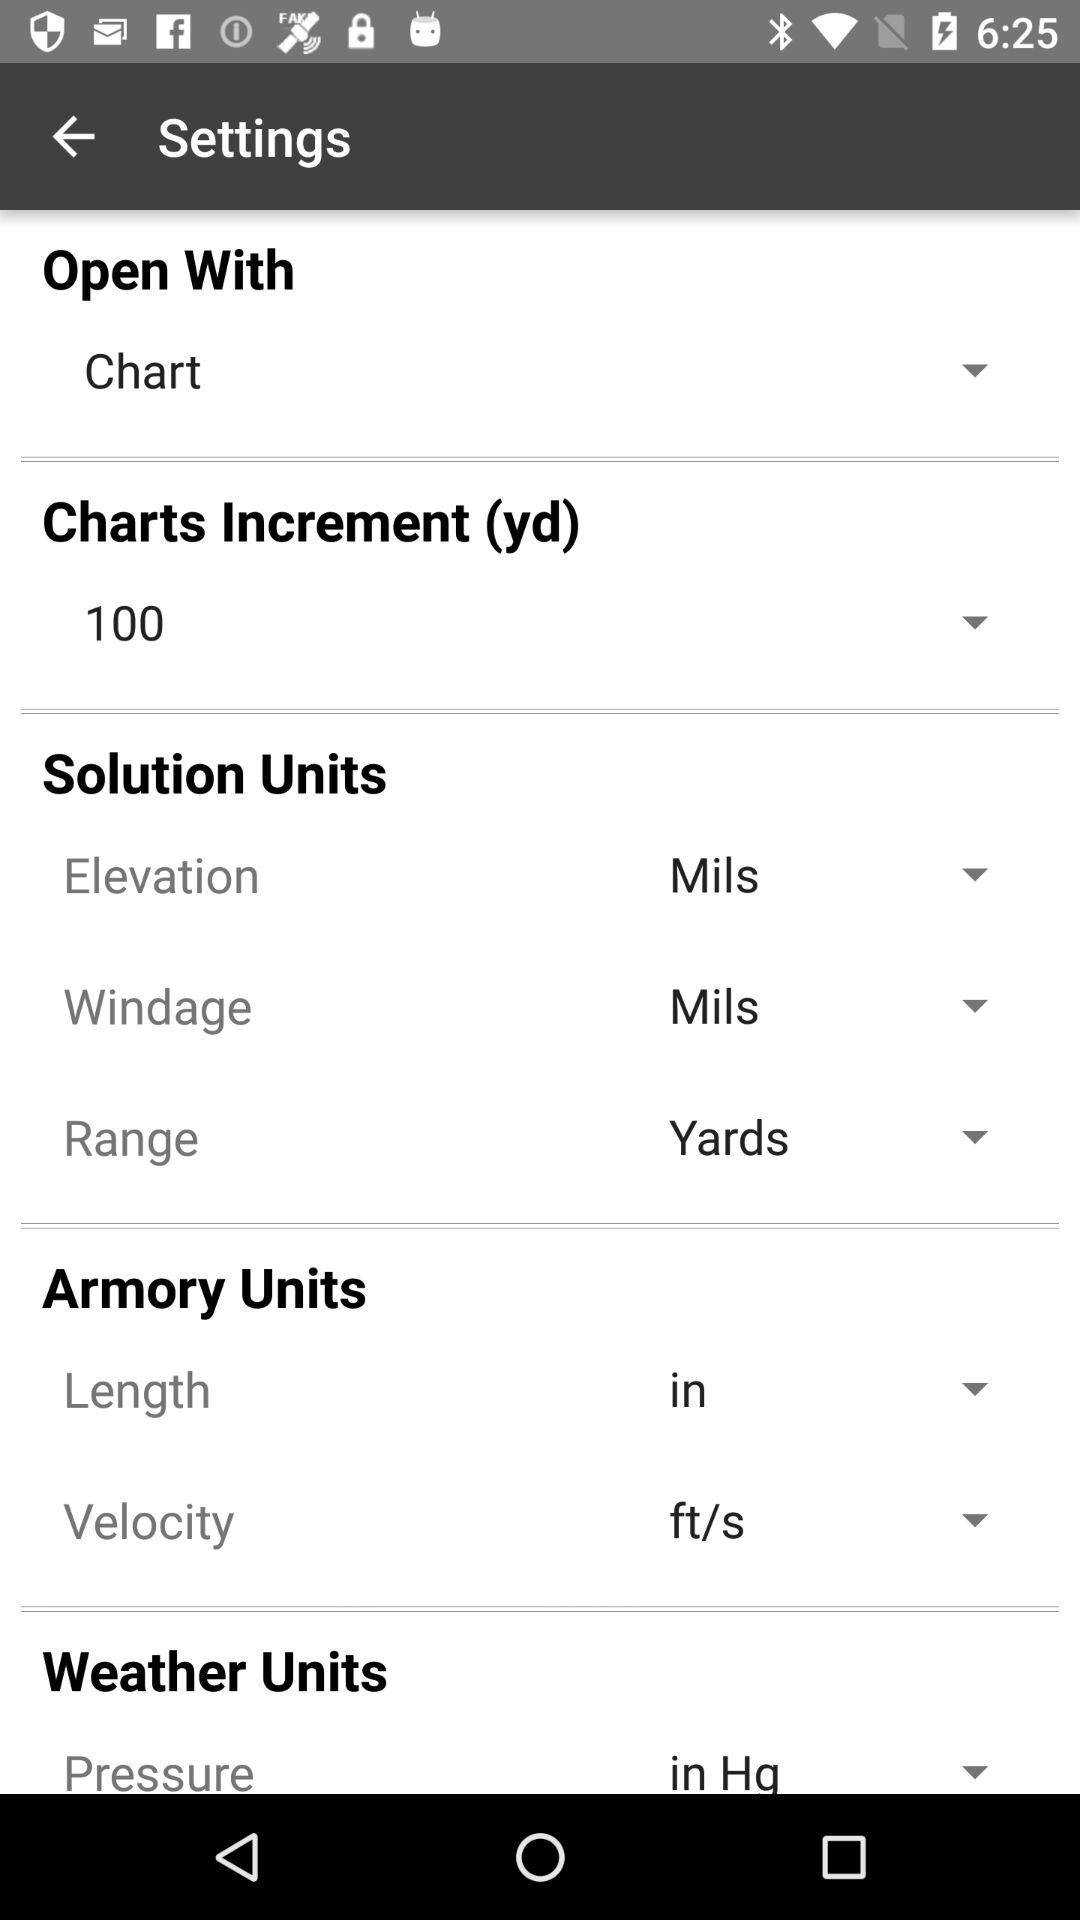Which chart increment is selected? The selected chart increment is 100. 